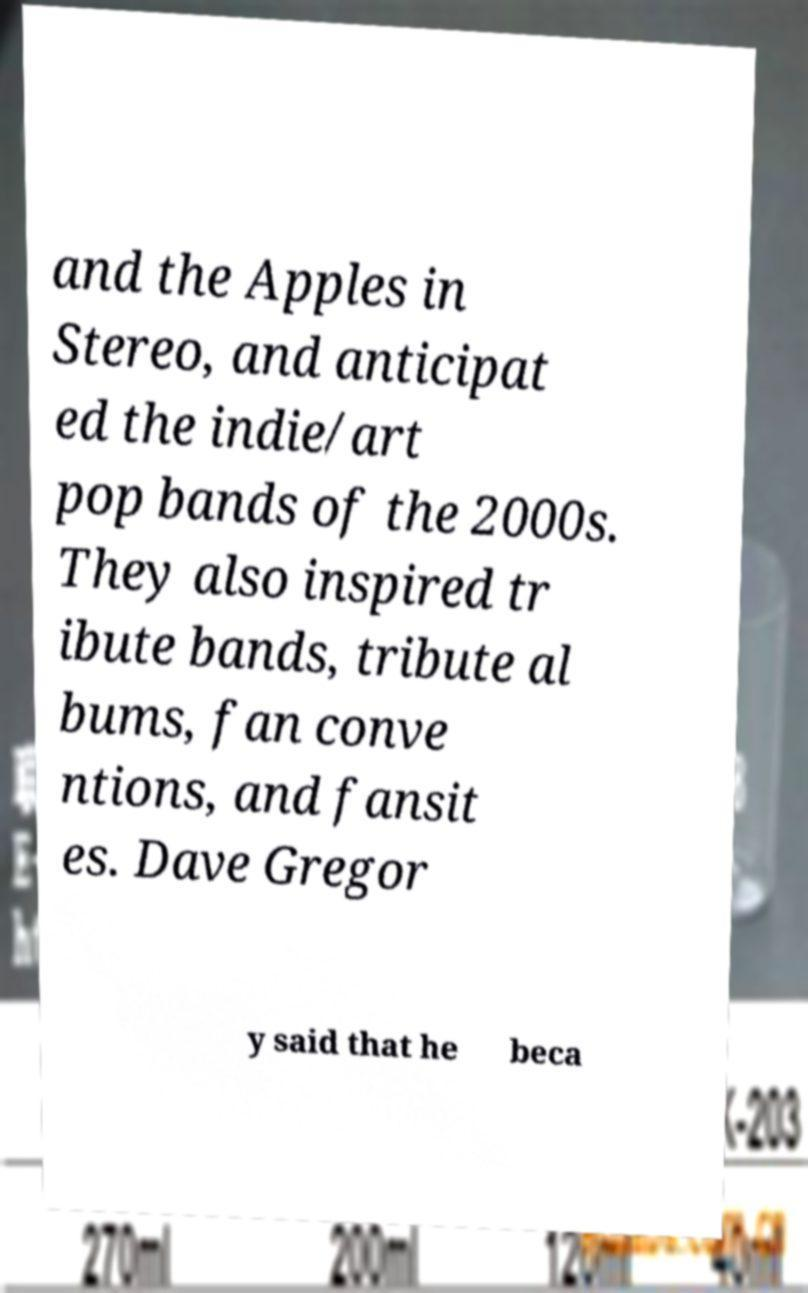Can you read and provide the text displayed in the image?This photo seems to have some interesting text. Can you extract and type it out for me? and the Apples in Stereo, and anticipat ed the indie/art pop bands of the 2000s. They also inspired tr ibute bands, tribute al bums, fan conve ntions, and fansit es. Dave Gregor y said that he beca 